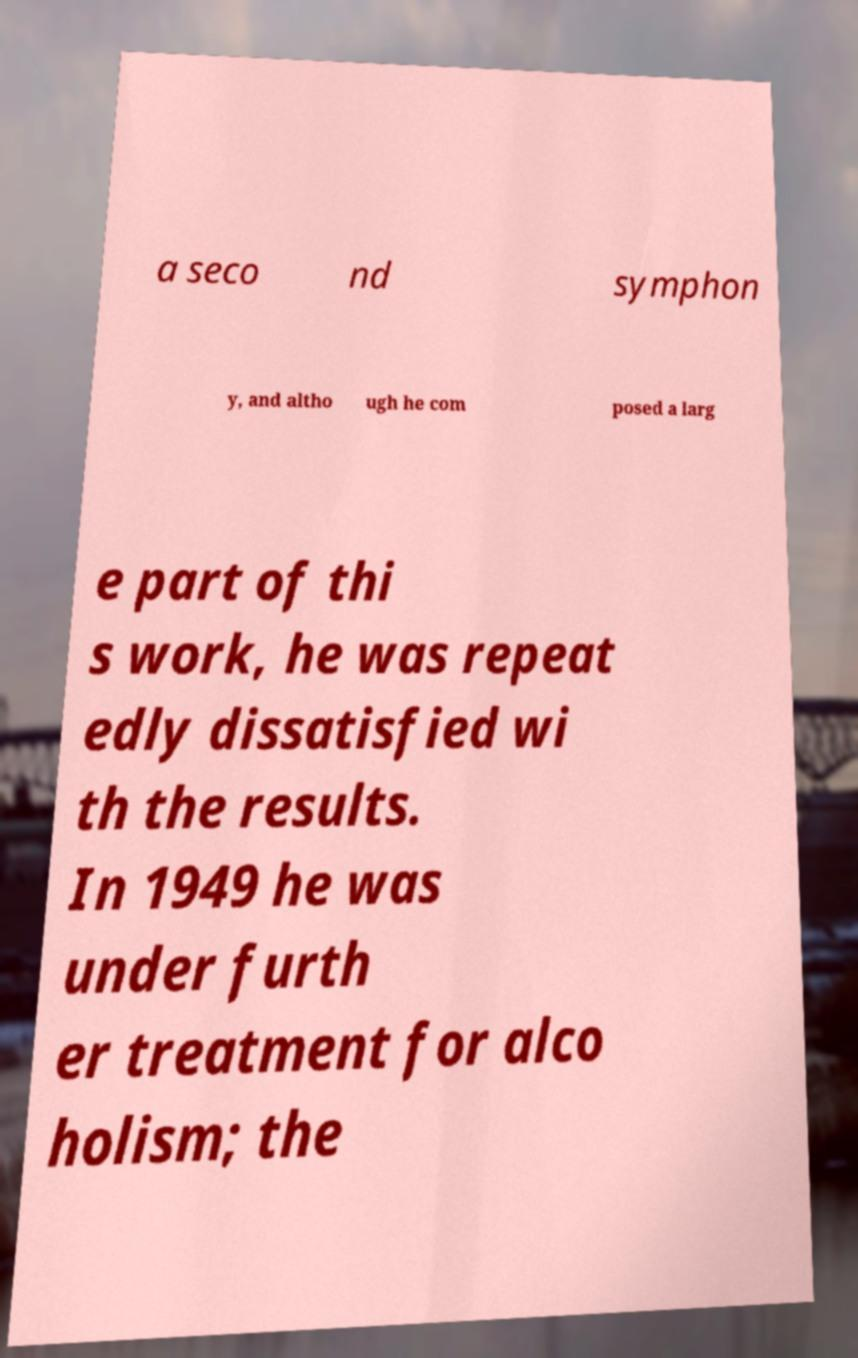Could you assist in decoding the text presented in this image and type it out clearly? a seco nd symphon y, and altho ugh he com posed a larg e part of thi s work, he was repeat edly dissatisfied wi th the results. In 1949 he was under furth er treatment for alco holism; the 